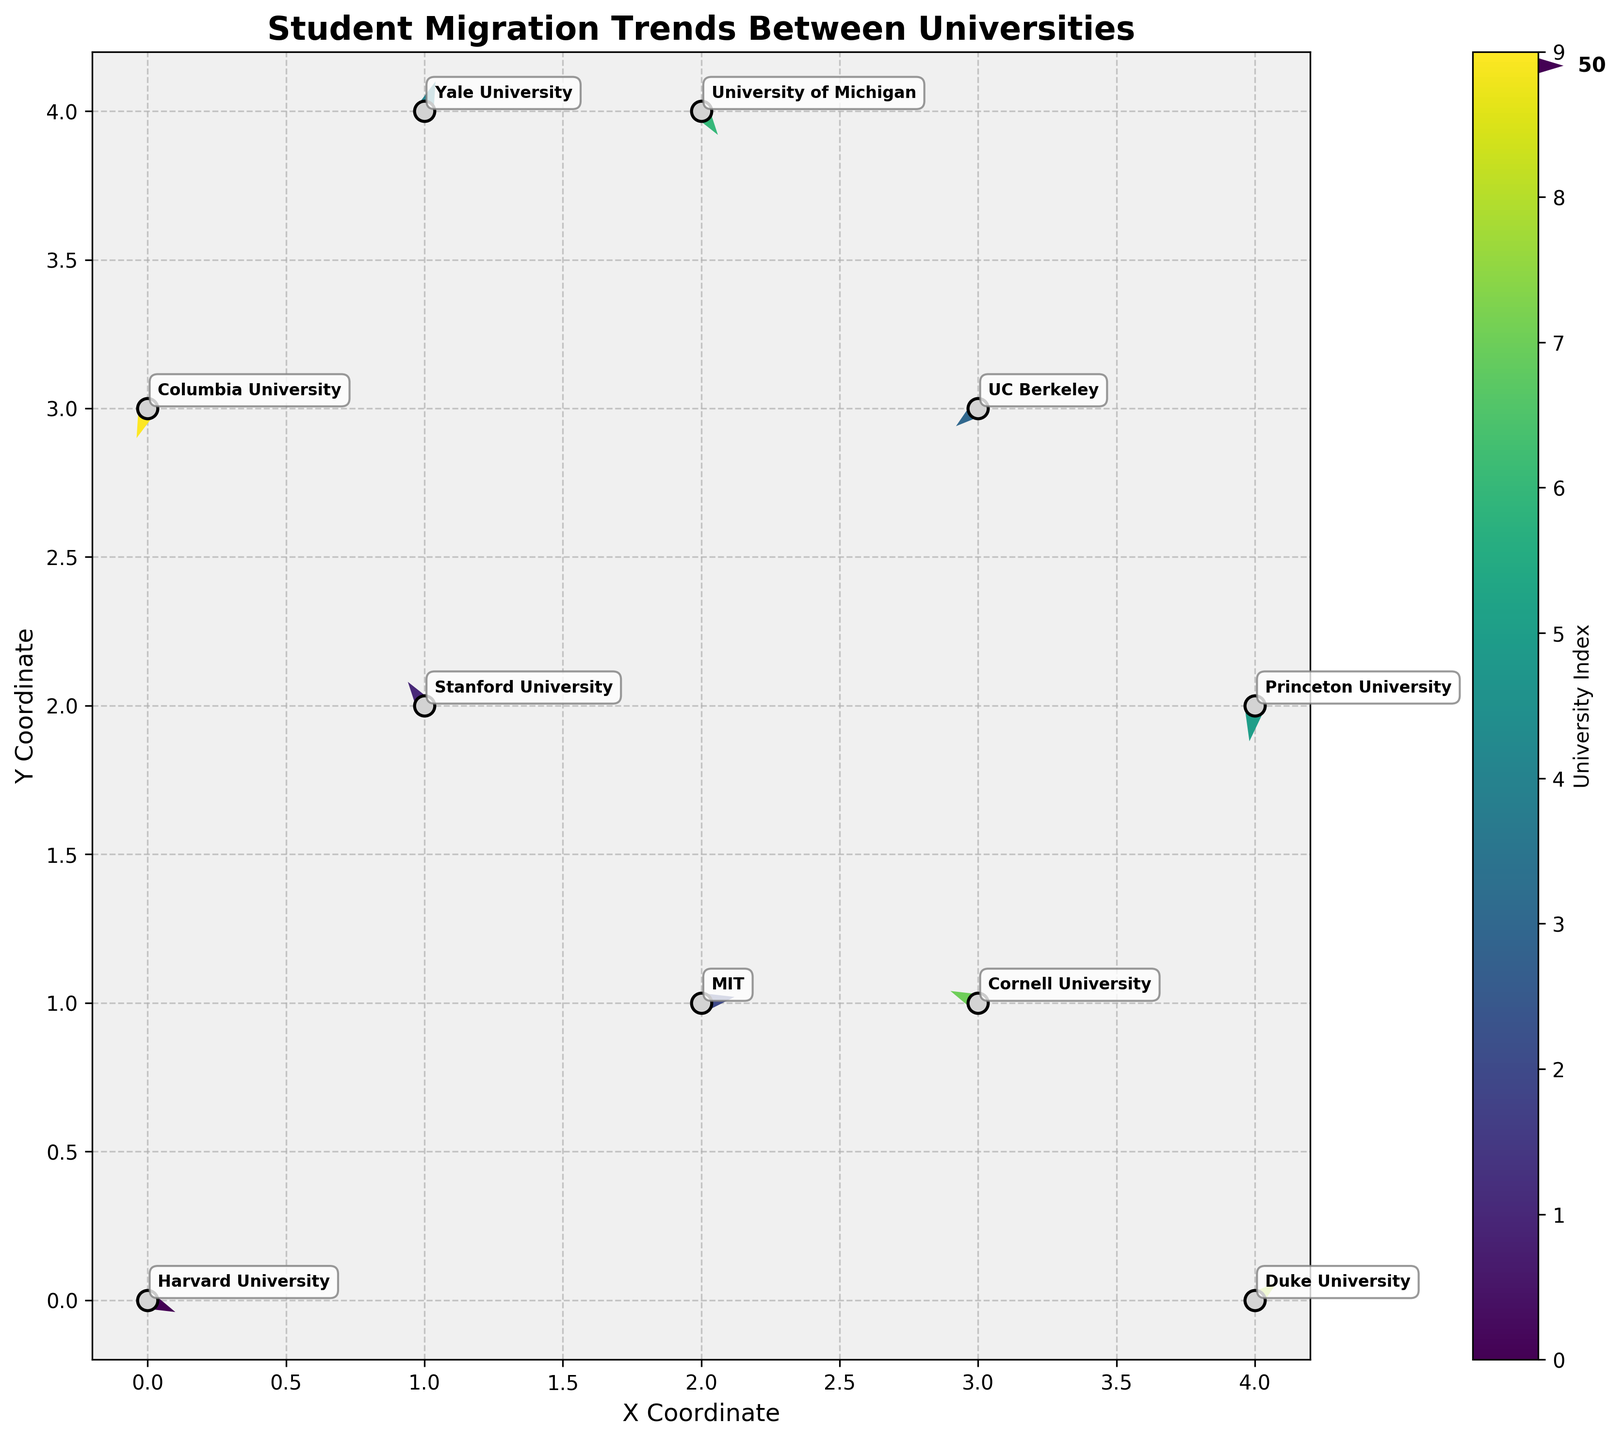Which university has the longest arrow in the quiver plot? The longest arrow represents the largest transfer of students. We evaluate the lengths by comparing arrow vector magnitudes using the formula √(U² + V²). Harvard University has the longest arrow with magnitude √(50² + (-20)²) = √(2500 + 400) = √2900 ≈ 53.85.
Answer: Harvard University What is the title of the plot? The title is displayed at the top of the plot, directly written there to describe the figure's content.
Answer: Student Migration Trends Between Universities Are there more universities with arrows pointing generally upwards or downwards? We examine the V component of each arrow. An arrow points generally upwards if V > 0, and downwards if V < 0. Upwards: Stanford (40), MIT (10), Yale (50), and Duke (30). Downwards: Harvard (-20), UC Berkeley (-30), Princeton (-60), Michigan (-40), Cornell (20), and Columbia (-50). Four arrows point upwards and six point downwards.
Answer: Downwards Which universities have arrows pointing towards the negative X direction? Arrows pointing towards the negative X (left) direction have U < 0. The universities are Stanford (-30), UC Berkeley (-40), Princeton (-10), Columbia (-20), and Cornell (-50).
Answer: Stanford, UC Berkeley, Princeton, Columbia, Cornell What is the color gradient used in the quiver plot? The color gradient can be seen from the visual cues provided, with colors transitioning. The specific gradient used is viridis, commonly ranging from purple/blue to green/yellow.
Answer: viridis How many universities have arrows with both positive U and V components? Arrows with positive U and V components point generally towards the top-right. The universities meeting this criterion are Yale (20, 50), Duke (40, 30), and MIT (60, 10).
Answer: Three For the university located at (1, 4), what direction does its arrow point to? The university at (1, 4) is Yale. Yale has an arrow with U = 20 and V = 50, pointing to the right and upward.
Answer: Upward and right Which university has the highest vertical transfer of students? The highest vertical transfer is found by comparing the absolute values of the V components. Princeton has the highest vertical component with V = -60.
Answer: Princeton What are the coordinates of the University of California, Berkeley on the plot? The coordinates of UC Berkeley are represented in the data section under X and Y values as (3, 3).
Answer: (3, 3) Do any universities have arrows pointing in nearly opposite directions? If yes, which ones? Nearly opposite directions would mean their U and V components are approximately inverses. Harvard (50, -20) and UC Berkeley (-40, -30); Duke (40, 30) and Columbia (-20, -50) represent pairs in near opposite directions.
Answer: Harvard and UC Berkeley; Duke and Columbia 